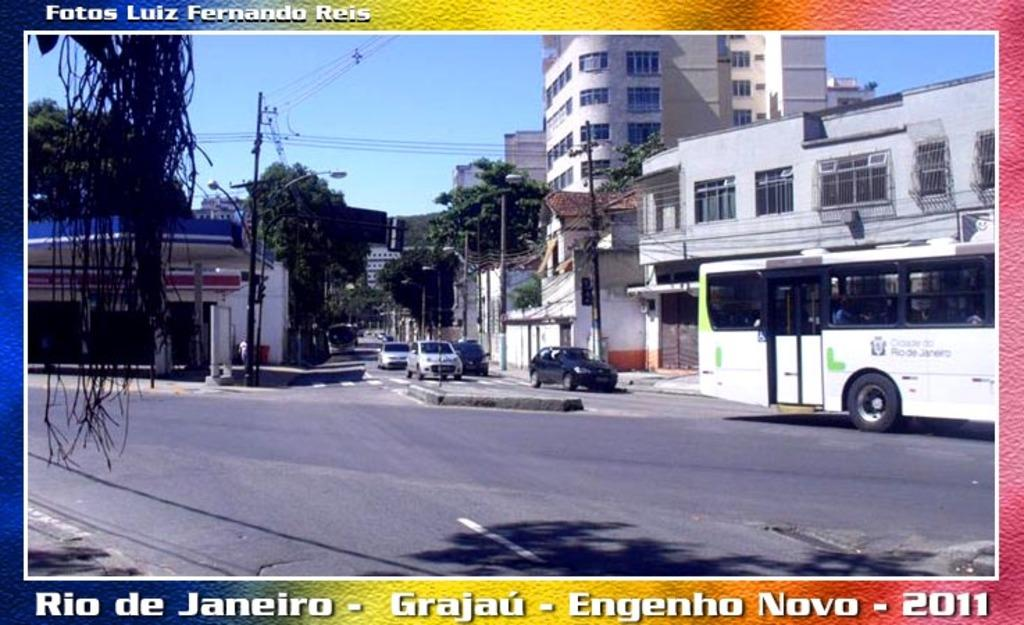Provide a one-sentence caption for the provided image. a postcard of rio de janeiro taken in 2011. 